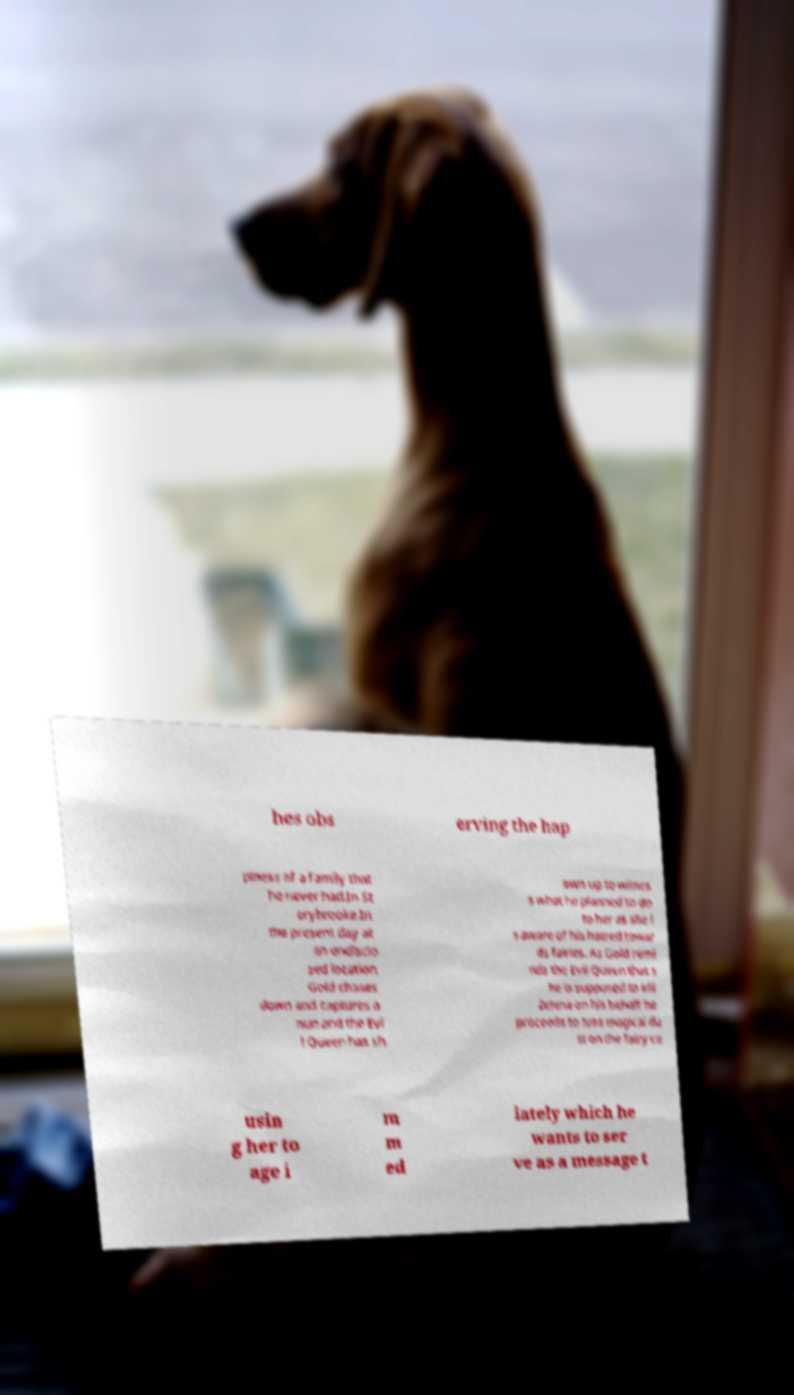I need the written content from this picture converted into text. Can you do that? hes obs erving the hap piness of a family that he never had.In St orybrooke.In the present day at an undisclo sed location Gold chases down and captures a nun and the Evi l Queen has sh own up to witnes s what he planned to do to her as she i s aware of his hatred towar ds fairies. As Gold remi nds the Evil Queen that s he is supposed to kill Zelena on his behalf he proceeds to toss magical du st on the fairy ca usin g her to age i m m ed iately which he wants to ser ve as a message t 